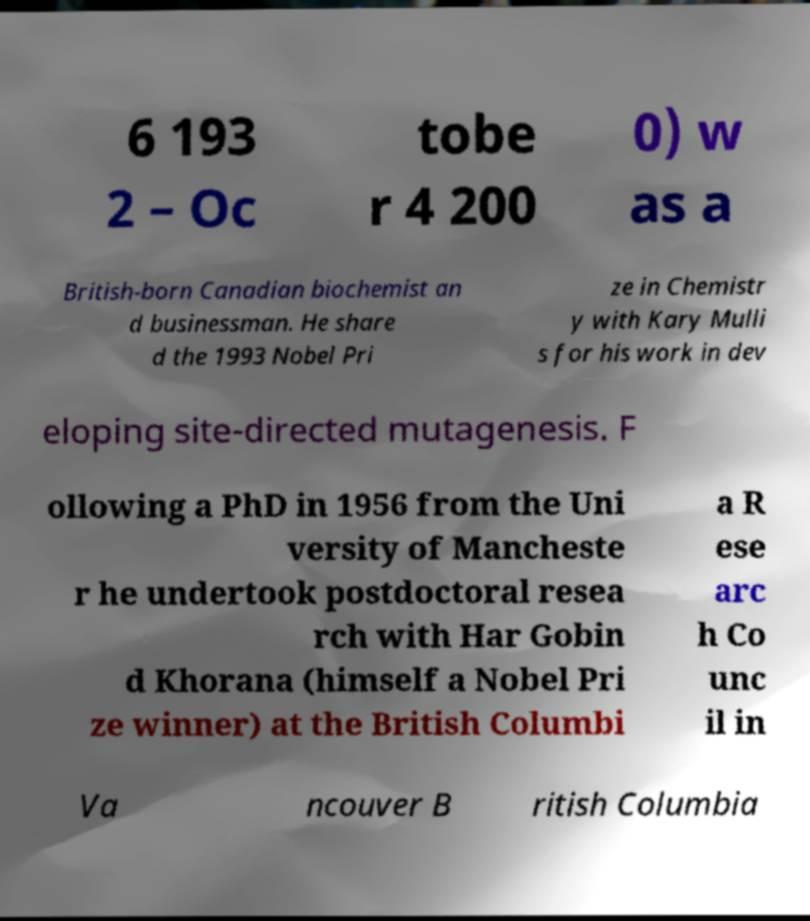Could you assist in decoding the text presented in this image and type it out clearly? 6 193 2 – Oc tobe r 4 200 0) w as a British-born Canadian biochemist an d businessman. He share d the 1993 Nobel Pri ze in Chemistr y with Kary Mulli s for his work in dev eloping site-directed mutagenesis. F ollowing a PhD in 1956 from the Uni versity of Mancheste r he undertook postdoctoral resea rch with Har Gobin d Khorana (himself a Nobel Pri ze winner) at the British Columbi a R ese arc h Co unc il in Va ncouver B ritish Columbia 